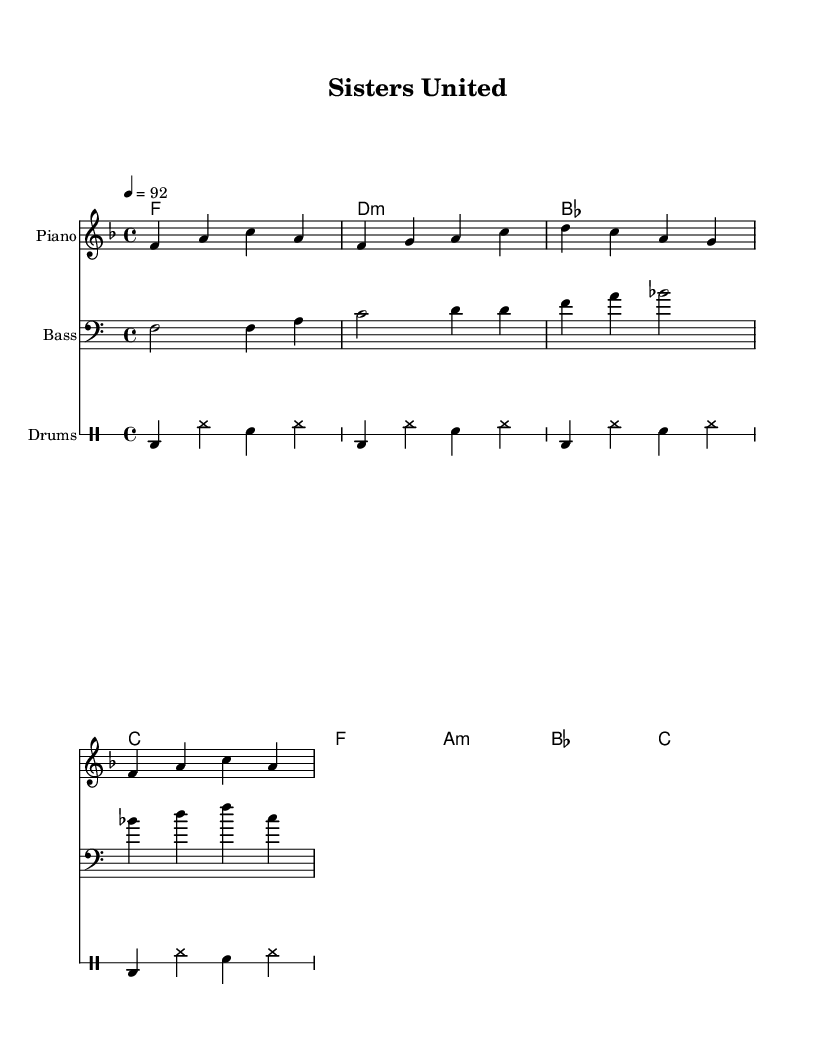What is the key signature of this music? The key signature indicates that the piece is in F major, which has one flat (B flat). This can be identified by looking at the key signature notation at the beginning of the staff.
Answer: F major What is the time signature of the music? The time signature is 4/4, which means there are four beats in each measure and that a quarter note gets one beat. This is displayed at the beginning of the score after the clef symbol.
Answer: 4/4 What is the tempo marking for this piece? The tempo marking is indicated as a following number and note (4 = 92), meaning the piece is to be played at a speed of 92 beats per minute. This is shown near the top of the music score.
Answer: 92 How many measures are there in the melody part? By counting the groups of notes divided by bar lines in the melody staff, we find there are four measures. Each measure is separated clearly by vertical bar lines on the staff.
Answer: 4 Which instrument is indicated for the bass part? The bass part is indicated to be played with a bass clef, which is found at the beginning of the bass staff. This defines the range of notes played by the instrument.
Answer: Bass What is the primary mood or theme conveyed through the music? The music consists of uplifting melodies and chords that celebrate unity and support in sisterhood. This can be inferred from the chord progression and the arrangement conducive to a positive and energetic feel typical in uplifting rap.
Answer: Uplifting 